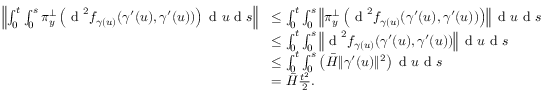Convert formula to latex. <formula><loc_0><loc_0><loc_500><loc_500>\begin{array} { r l } { \left \| \int _ { 0 } ^ { t } \int _ { 0 } ^ { s } \pi _ { y } ^ { \perp } \left ( d ^ { 2 } f _ { \gamma ( u ) } ( \gamma ^ { \prime } ( u ) , \gamma ^ { \prime } ( u ) ) \right ) d u d s \right \| } & { \leq \int _ { 0 } ^ { t } \int _ { 0 } ^ { s } \left \| \pi _ { y } ^ { \perp } \left ( d ^ { 2 } f _ { \gamma ( u ) } ( \gamma ^ { \prime } ( u ) , \gamma ^ { \prime } ( u ) ) \right ) \right \| d u d s } \\ & { \leq \int _ { 0 } ^ { t } \int _ { 0 } ^ { s } \left \| d ^ { 2 } f _ { \gamma ( u ) } ( \gamma ^ { \prime } ( u ) , \gamma ^ { \prime } ( u ) ) \right \| d u d s } \\ & { \leq \int _ { 0 } ^ { t } \int _ { 0 } ^ { s } \left ( \bar { H } \| \gamma ^ { \prime } ( u ) \| ^ { 2 } \right ) d u d s } \\ & { = \bar { H } \frac { t ^ { 2 } } { 2 } . } \end{array}</formula> 